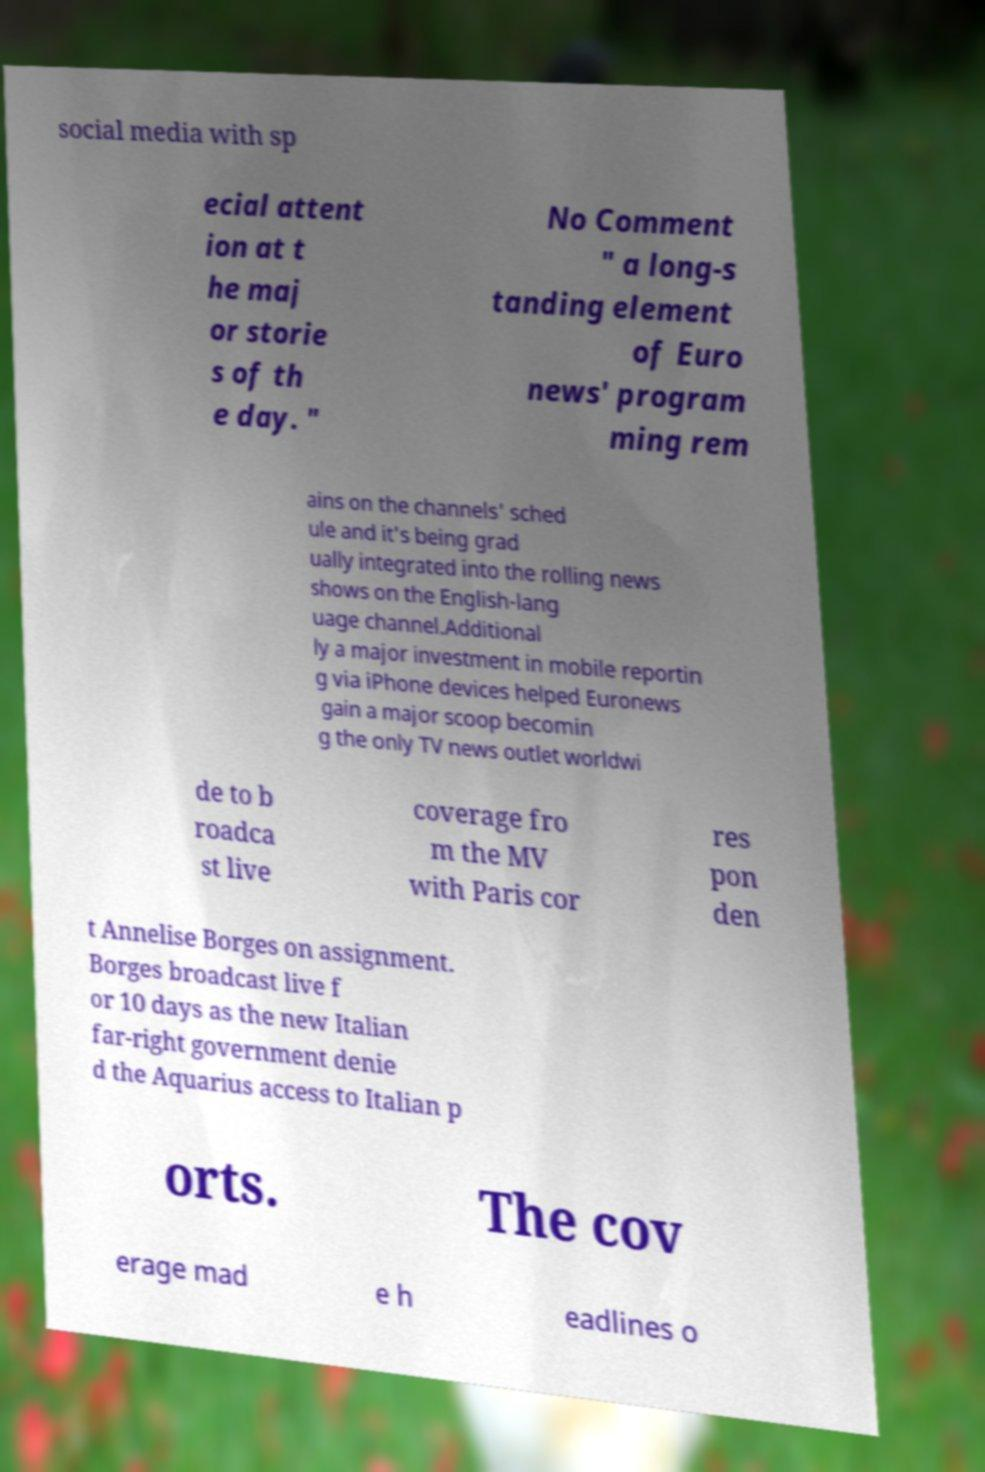I need the written content from this picture converted into text. Can you do that? social media with sp ecial attent ion at t he maj or storie s of th e day. " No Comment " a long-s tanding element of Euro news' program ming rem ains on the channels' sched ule and it's being grad ually integrated into the rolling news shows on the English-lang uage channel.Additional ly a major investment in mobile reportin g via iPhone devices helped Euronews gain a major scoop becomin g the only TV news outlet worldwi de to b roadca st live coverage fro m the MV with Paris cor res pon den t Annelise Borges on assignment. Borges broadcast live f or 10 days as the new Italian far-right government denie d the Aquarius access to Italian p orts. The cov erage mad e h eadlines o 